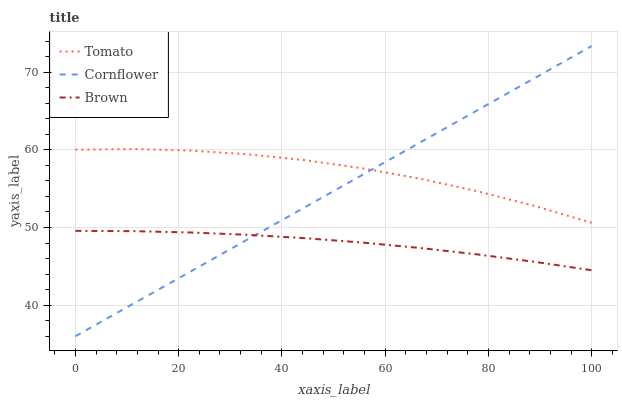Does Brown have the minimum area under the curve?
Answer yes or no. Yes. Does Tomato have the maximum area under the curve?
Answer yes or no. Yes. Does Cornflower have the minimum area under the curve?
Answer yes or no. No. Does Cornflower have the maximum area under the curve?
Answer yes or no. No. Is Cornflower the smoothest?
Answer yes or no. Yes. Is Tomato the roughest?
Answer yes or no. Yes. Is Brown the smoothest?
Answer yes or no. No. Is Brown the roughest?
Answer yes or no. No. Does Brown have the lowest value?
Answer yes or no. No. Does Cornflower have the highest value?
Answer yes or no. Yes. Does Brown have the highest value?
Answer yes or no. No. Is Brown less than Tomato?
Answer yes or no. Yes. Is Tomato greater than Brown?
Answer yes or no. Yes. Does Brown intersect Tomato?
Answer yes or no. No. 